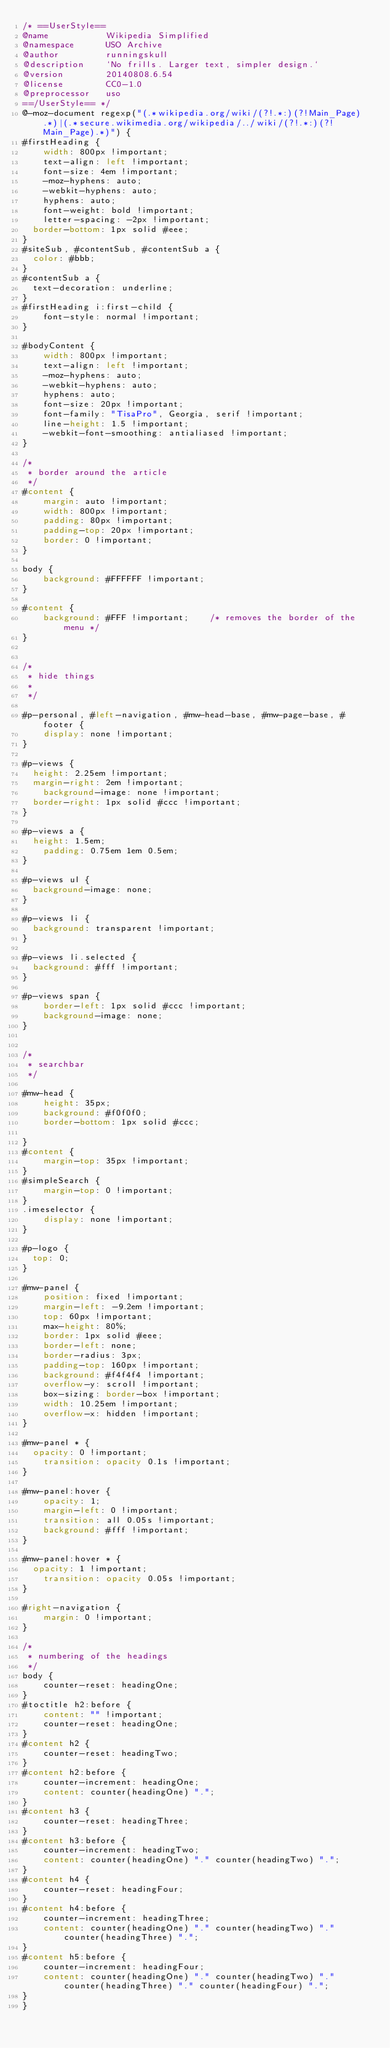Convert code to text. <code><loc_0><loc_0><loc_500><loc_500><_CSS_>/* ==UserStyle==
@name           Wikipedia Simplified
@namespace      USO Archive
@author         runningskull
@description    `No frills. Larger text, simpler design.`
@version        20140808.6.54
@license        CC0-1.0
@preprocessor   uso
==/UserStyle== */
@-moz-document regexp("(.*wikipedia.org/wiki/(?!.*:)(?!Main_Page).*)|(.*secure.wikimedia.org/wikipedia/../wiki/(?!.*:)(?!Main_Page).*)") {
#firstHeading {
    width: 800px !important;
    text-align: left !important;
    font-size: 4em !important;
    -moz-hyphens: auto;
    -webkit-hyphens: auto;
    hyphens: auto;
    font-weight: bold !important;
    letter-spacing: -2px !important;
	border-bottom: 1px solid #eee;
}
#siteSub, #contentSub, #contentSub a {
	color: #bbb;
}
#contentSub a {
	text-decoration: underline;
}
#firstHeading i:first-child {
    font-style: normal !important;
}

#bodyContent {
    width: 800px !important;
    text-align: left !important;
    -moz-hyphens: auto;
    -webkit-hyphens: auto;
    hyphens: auto;
    font-size: 20px !important;
  	font-family: "TisaPro", Georgia, serif !important;
  	line-height: 1.5 !important;
  	-webkit-font-smoothing: antialiased !important;
}

/*
 * border around the article
 */
#content {
    margin: auto !important; 
    width: 800px !important;
    padding: 80px !important; 
    padding-top: 20px !important;
    border: 0 !important;
}

body {
    background: #FFFFFF !important;
}

#content {
    background: #FFF !important;    /* removes the border of the menu */
}


/*
 * hide things
 *
 */

#p-personal, #left-navigation, #mw-head-base, #mw-page-base, #footer {
    display: none !important;
}

#p-views {
	height: 2.25em !important;
	margin-right: 2em !important;
  	background-image: none !important;
  border-right: 1px solid #ccc !important;
}

#p-views a {
	height: 1.5em;
    padding: 0.75em 1em 0.5em;
}

#p-views ul {
  background-image: none;
}

#p-views li {
	background: transparent !important;
}

#p-views li.selected {
	background: #fff !important;
}

#p-views span {
    border-left: 1px solid #ccc !important;
    background-image: none;
}


/*
 * searchbar
 */

#mw-head {
    height: 35px;
    background: #f0f0f0;   
    border-bottom: 1px solid #ccc;

}
#content {
    margin-top: 35px !important;
}
#simpleSearch {
    margin-top: 0 !important;
}
.imeselector {
    display: none !important;
}

#p-logo {
	top: 0;
}

#mw-panel {
  	position: fixed !important;
  	margin-left: -9.2em !important;
    top: 60px !important;
  	max-height: 80%;
  	border: 1px solid #eee;
  	border-left: none;
  	border-radius: 3px;
  	padding-top: 160px !important;
  	background: #f4f4f4 !important;
  	overflow-y: scroll !important;
  	box-sizing: border-box !important;
  	width: 10.25em !important;
  	overflow-x: hidden !important;
}

#mw-panel * {
	opacity: 0 !important;
  	transition: opacity 0.1s !important;
}

#mw-panel:hover {
    opacity: 1;
  	margin-left: 0 !important;
  	transition: all 0.05s !important;
  	background: #fff !important;
}

#mw-panel:hover * {
	opacity: 1 !important;
  	transition: opacity 0.05s !important;
}

#right-navigation {
    margin: 0 !important;
}

/*
 * numbering of the headings
 */
body {
    counter-reset: headingOne;
}
#toctitle h2:before {
    content: "" !important;
    counter-reset: headingOne;
}
#content h2 {
    counter-reset: headingTwo;
}
#content h2:before {
    counter-increment: headingOne;
    content: counter(headingOne) ".";
}
#content h3 {
    counter-reset: headingThree;
}
#content h3:before {
    counter-increment: headingTwo;		
    content: counter(headingOne) "." counter(headingTwo) ".";
}
#content h4 {
    counter-reset: headingFour;
}
#content h4:before {
    counter-increment: headingThree;
    content: counter(headingOne) "." counter(headingTwo) "." counter(headingThree) ".";
}
#content h5:before {
    counter-increment: headingFour;
    content: counter(headingOne) "." counter(headingTwo) "." counter(headingThree) "." counter(headingFour) ".";
}
}</code> 